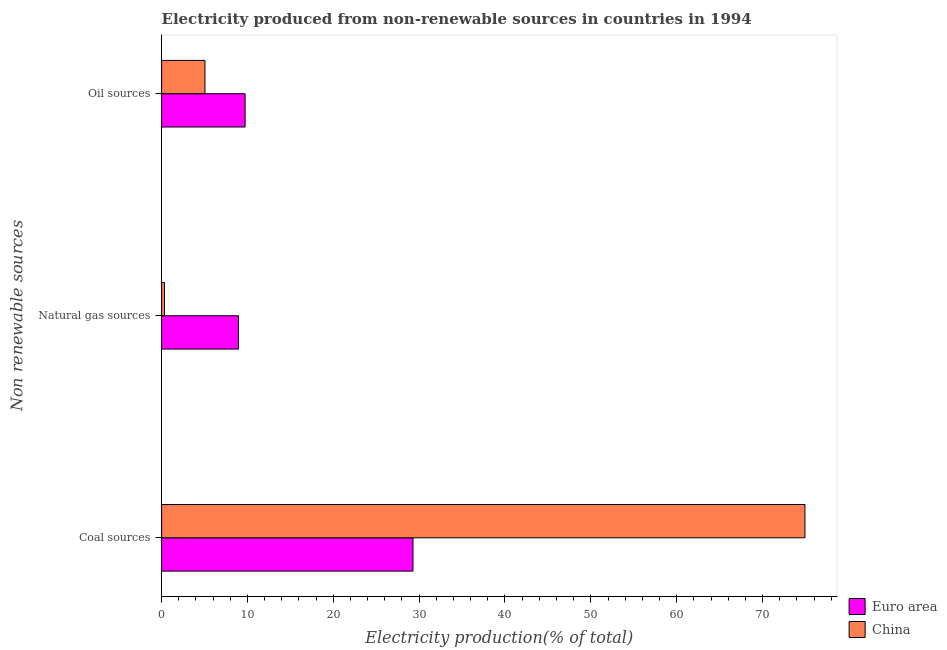How many different coloured bars are there?
Ensure brevity in your answer.  2. Are the number of bars on each tick of the Y-axis equal?
Your response must be concise. Yes. What is the label of the 2nd group of bars from the top?
Ensure brevity in your answer.  Natural gas sources. What is the percentage of electricity produced by oil sources in China?
Keep it short and to the point. 5.05. Across all countries, what is the maximum percentage of electricity produced by natural gas?
Your answer should be very brief. 8.95. Across all countries, what is the minimum percentage of electricity produced by coal?
Keep it short and to the point. 29.28. What is the total percentage of electricity produced by natural gas in the graph?
Offer a terse response. 9.29. What is the difference between the percentage of electricity produced by oil sources in China and that in Euro area?
Make the answer very short. -4.68. What is the difference between the percentage of electricity produced by oil sources in China and the percentage of electricity produced by coal in Euro area?
Ensure brevity in your answer.  -24.23. What is the average percentage of electricity produced by coal per country?
Your response must be concise. 52.11. What is the difference between the percentage of electricity produced by natural gas and percentage of electricity produced by coal in Euro area?
Give a very brief answer. -20.33. In how many countries, is the percentage of electricity produced by oil sources greater than 24 %?
Your answer should be very brief. 0. What is the ratio of the percentage of electricity produced by natural gas in Euro area to that in China?
Your answer should be very brief. 26.41. What is the difference between the highest and the second highest percentage of electricity produced by coal?
Offer a terse response. 45.66. What is the difference between the highest and the lowest percentage of electricity produced by natural gas?
Offer a terse response. 8.61. In how many countries, is the percentage of electricity produced by coal greater than the average percentage of electricity produced by coal taken over all countries?
Provide a short and direct response. 1. What does the 1st bar from the top in Natural gas sources represents?
Provide a succinct answer. China. How many countries are there in the graph?
Make the answer very short. 2. Does the graph contain any zero values?
Offer a very short reply. No. Does the graph contain grids?
Offer a very short reply. No. How many legend labels are there?
Provide a succinct answer. 2. How are the legend labels stacked?
Provide a short and direct response. Vertical. What is the title of the graph?
Ensure brevity in your answer.  Electricity produced from non-renewable sources in countries in 1994. Does "Nepal" appear as one of the legend labels in the graph?
Keep it short and to the point. No. What is the label or title of the X-axis?
Give a very brief answer. Electricity production(% of total). What is the label or title of the Y-axis?
Your answer should be very brief. Non renewable sources. What is the Electricity production(% of total) of Euro area in Coal sources?
Offer a very short reply. 29.28. What is the Electricity production(% of total) in China in Coal sources?
Your answer should be compact. 74.94. What is the Electricity production(% of total) of Euro area in Natural gas sources?
Offer a very short reply. 8.95. What is the Electricity production(% of total) in China in Natural gas sources?
Offer a very short reply. 0.34. What is the Electricity production(% of total) in Euro area in Oil sources?
Your answer should be compact. 9.73. What is the Electricity production(% of total) in China in Oil sources?
Your answer should be compact. 5.05. Across all Non renewable sources, what is the maximum Electricity production(% of total) in Euro area?
Give a very brief answer. 29.28. Across all Non renewable sources, what is the maximum Electricity production(% of total) in China?
Ensure brevity in your answer.  74.94. Across all Non renewable sources, what is the minimum Electricity production(% of total) of Euro area?
Your response must be concise. 8.95. Across all Non renewable sources, what is the minimum Electricity production(% of total) of China?
Keep it short and to the point. 0.34. What is the total Electricity production(% of total) in Euro area in the graph?
Your response must be concise. 47.97. What is the total Electricity production(% of total) of China in the graph?
Give a very brief answer. 80.33. What is the difference between the Electricity production(% of total) of Euro area in Coal sources and that in Natural gas sources?
Your response must be concise. 20.33. What is the difference between the Electricity production(% of total) of China in Coal sources and that in Natural gas sources?
Offer a very short reply. 74.6. What is the difference between the Electricity production(% of total) in Euro area in Coal sources and that in Oil sources?
Your response must be concise. 19.55. What is the difference between the Electricity production(% of total) of China in Coal sources and that in Oil sources?
Offer a terse response. 69.89. What is the difference between the Electricity production(% of total) of Euro area in Natural gas sources and that in Oil sources?
Your response must be concise. -0.78. What is the difference between the Electricity production(% of total) in China in Natural gas sources and that in Oil sources?
Provide a succinct answer. -4.71. What is the difference between the Electricity production(% of total) in Euro area in Coal sources and the Electricity production(% of total) in China in Natural gas sources?
Keep it short and to the point. 28.94. What is the difference between the Electricity production(% of total) in Euro area in Coal sources and the Electricity production(% of total) in China in Oil sources?
Offer a very short reply. 24.23. What is the difference between the Electricity production(% of total) in Euro area in Natural gas sources and the Electricity production(% of total) in China in Oil sources?
Provide a short and direct response. 3.9. What is the average Electricity production(% of total) in Euro area per Non renewable sources?
Your response must be concise. 15.99. What is the average Electricity production(% of total) in China per Non renewable sources?
Make the answer very short. 26.78. What is the difference between the Electricity production(% of total) in Euro area and Electricity production(% of total) in China in Coal sources?
Provide a succinct answer. -45.66. What is the difference between the Electricity production(% of total) of Euro area and Electricity production(% of total) of China in Natural gas sources?
Your answer should be compact. 8.61. What is the difference between the Electricity production(% of total) in Euro area and Electricity production(% of total) in China in Oil sources?
Your answer should be compact. 4.68. What is the ratio of the Electricity production(% of total) of Euro area in Coal sources to that in Natural gas sources?
Offer a very short reply. 3.27. What is the ratio of the Electricity production(% of total) in China in Coal sources to that in Natural gas sources?
Your answer should be very brief. 221.08. What is the ratio of the Electricity production(% of total) in Euro area in Coal sources to that in Oil sources?
Your response must be concise. 3.01. What is the ratio of the Electricity production(% of total) in China in Coal sources to that in Oil sources?
Provide a succinct answer. 14.83. What is the ratio of the Electricity production(% of total) in Euro area in Natural gas sources to that in Oil sources?
Offer a very short reply. 0.92. What is the ratio of the Electricity production(% of total) in China in Natural gas sources to that in Oil sources?
Your answer should be compact. 0.07. What is the difference between the highest and the second highest Electricity production(% of total) in Euro area?
Your response must be concise. 19.55. What is the difference between the highest and the second highest Electricity production(% of total) of China?
Your answer should be very brief. 69.89. What is the difference between the highest and the lowest Electricity production(% of total) of Euro area?
Ensure brevity in your answer.  20.33. What is the difference between the highest and the lowest Electricity production(% of total) in China?
Give a very brief answer. 74.6. 